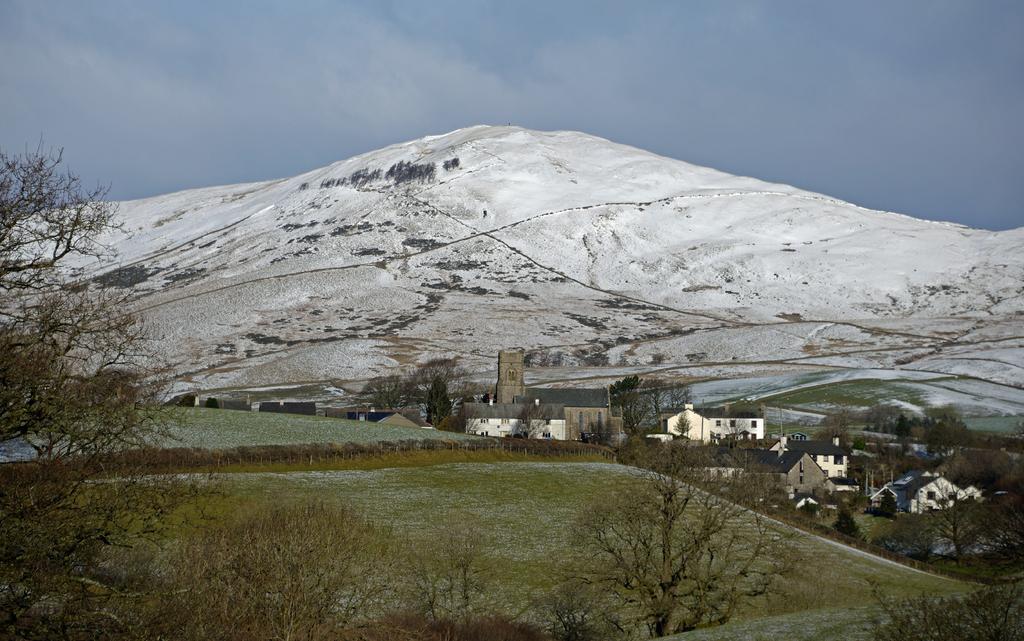Describe this image in one or two sentences. In the picture we can see some trees and near to it, we can see crops and near it, we can see some houses and trees behind it, we can see a hill which is covered with snow and behind it we can see a sky with clouds. 